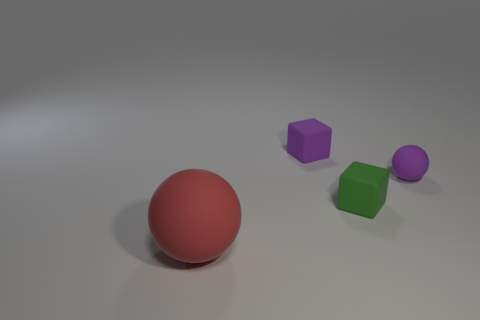Add 1 gray cubes. How many objects exist? 5 Subtract all purple cubes. Subtract all purple matte cubes. How many objects are left? 2 Add 2 rubber cubes. How many rubber cubes are left? 4 Add 3 big green metal cylinders. How many big green metal cylinders exist? 3 Subtract 1 red spheres. How many objects are left? 3 